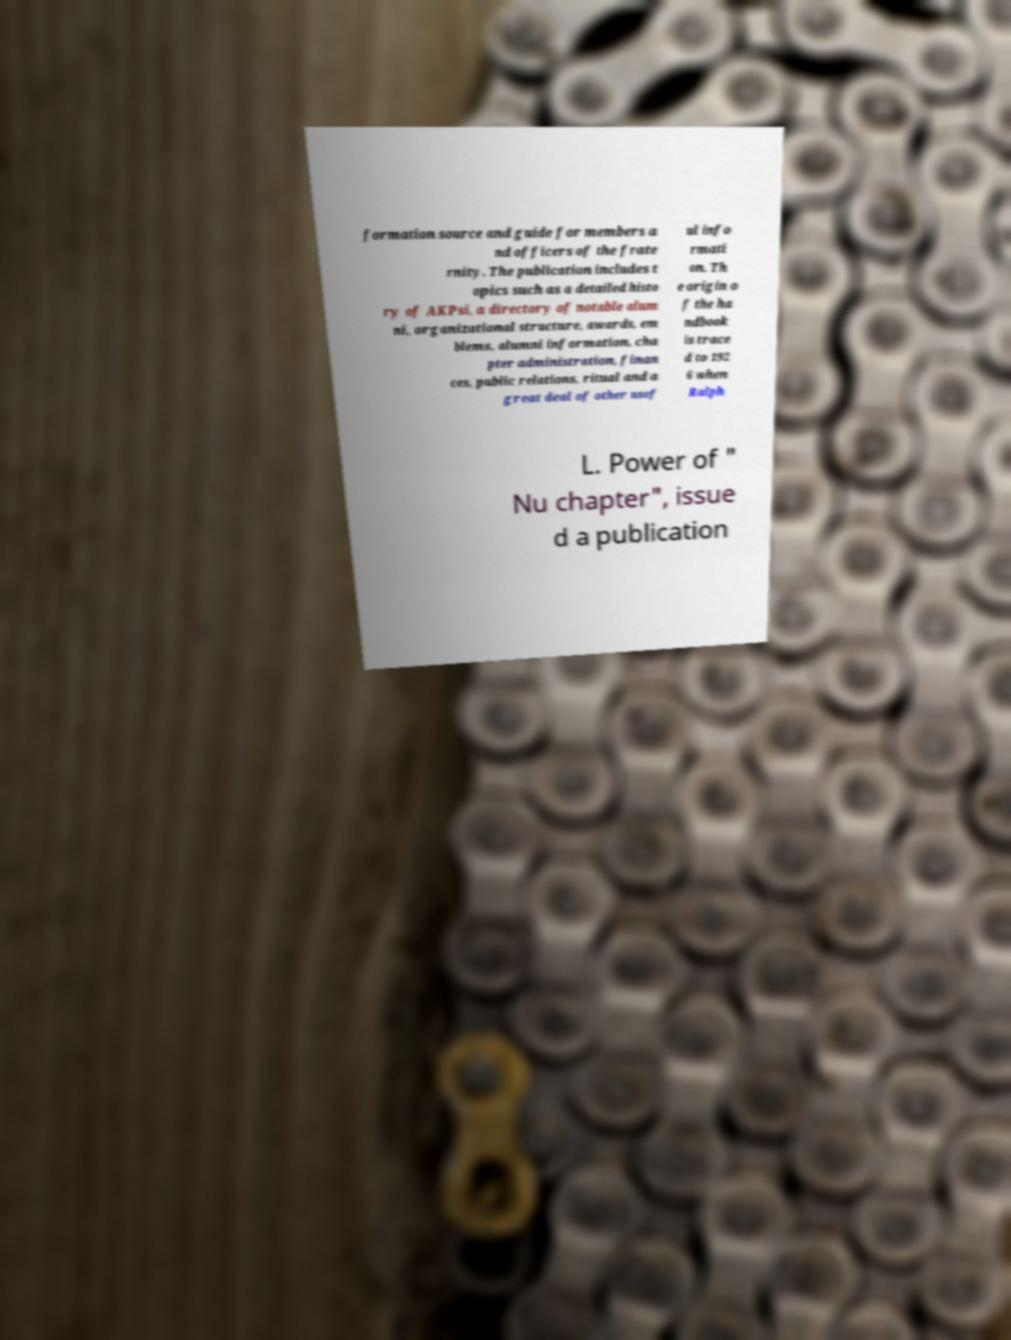I need the written content from this picture converted into text. Can you do that? formation source and guide for members a nd officers of the frate rnity. The publication includes t opics such as a detailed histo ry of AKPsi, a directory of notable alum ni, organizational structure, awards, em blems, alumni information, cha pter administration, finan ces, public relations, ritual and a great deal of other usef ul info rmati on. Th e origin o f the ha ndbook is trace d to 192 6 when Ralph L. Power of " Nu chapter", issue d a publication 